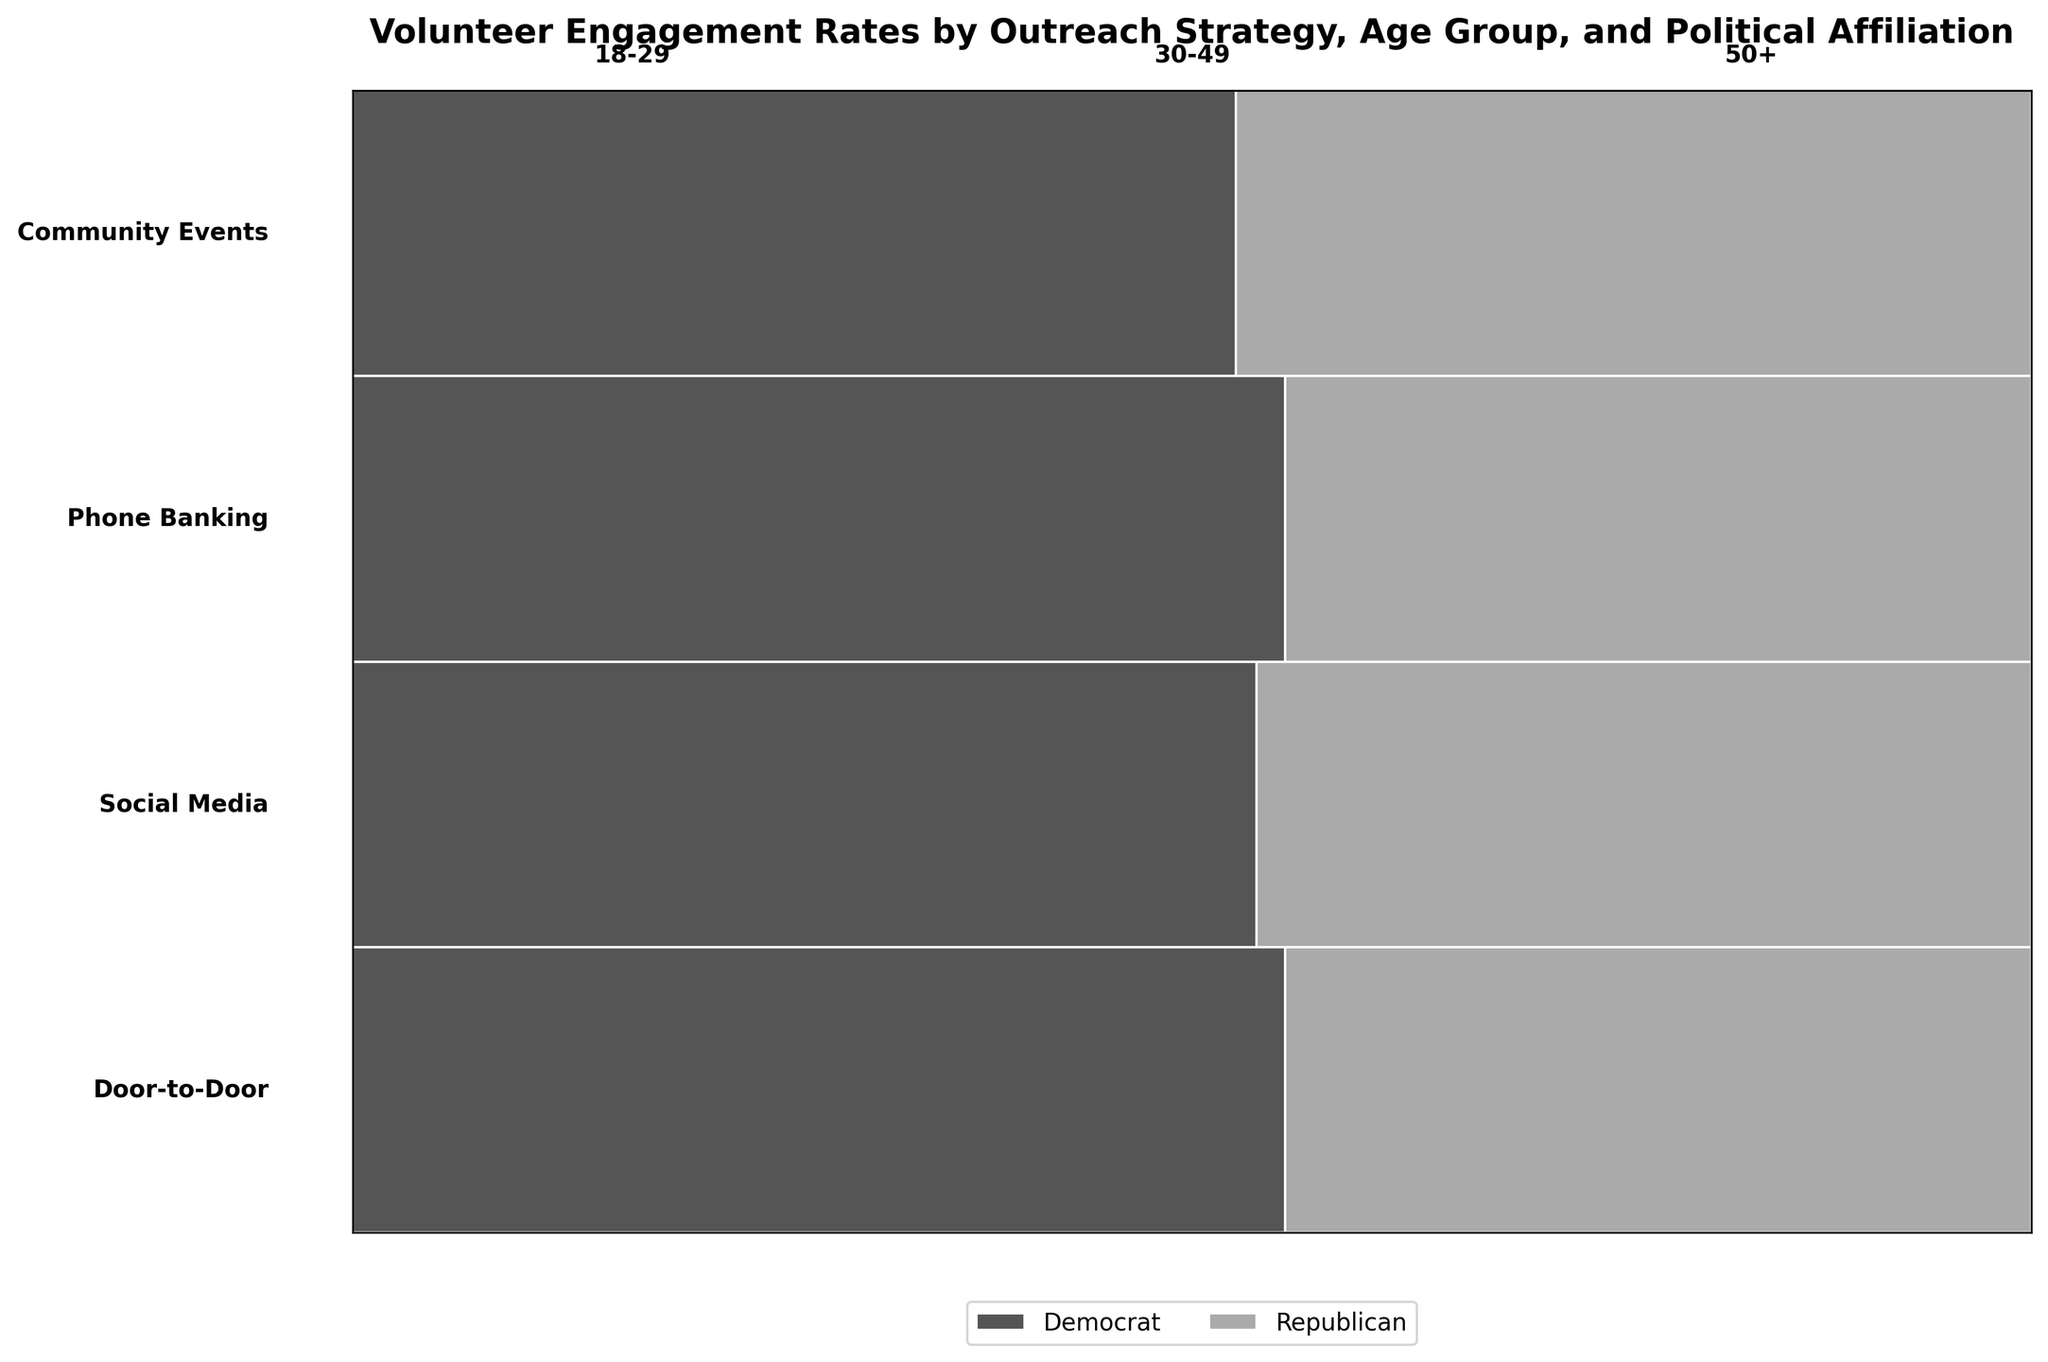Which outreach strategy has the highest engagement rate for the 18-29 age group? To find the highest engagement rate for the 18-29 age group, look at the respective sections for each outreach strategy for this age group and compare the engagement rates. The 'Social Media' strategy shows the highest engagement rate for the 18-29 age group.
Answer: Social Media Which age group shows the highest engagement rate in the 'Door-to-Door' strategy for Democrats? Examine the 'Door-to-Door' strategy and look at each age group's engagement rate for Democrats. The 50+ age group has the highest engagement rate among Democrats in the 'Door-to-Door' strategy.
Answer: 50+ What is the difference in engagement rates between Democrats and Republicans for the 'Social Media' strategy in the 30-49 age group? Locate the 'Social Media' strategy for the 30-49 age group and find the engagement rates for Democrats and Republicans. Subtract the Republican rate from the Democratic rate: 0.25 - 0.22 = 0.03.
Answer: 0.03 How do the engagement rates of 'Phone Banking' compare between Democrats and Republicans for the 50+ age group? Compare the engagement rates within the 'Phone Banking' for the 50+ age group. Democrats have a rate of 0.25, while Republicans have a rate of 0.22, making Democrats' engagement slightly higher.
Answer: Democrats have a higher rate Which outreach strategy has the lowest engagement rate for the 18-29 age group, irrespective of political affiliation? Identify the engagement rates for the 18-29 age group across all outreach strategies. The lowest rate is seen in the 'Phone Banking' strategy.
Answer: Phone Banking In which outreach strategy do Republicans in the 30-49 age group show higher engagement rates compared to Democrats in the same age group? Look for sections comparing engagement rates for Democrats and Republicans in the 30-49 age group across all strategies. None of the strategies show higher engagement rates for Republicans compared to Democrats in this age group.
Answer: None Which strategy has the most balanced engagement rates between Democrats and Republicans for the 50+ age group? Check the engagement rates for both Democrats and Republicans in the 50+ age group across all strategies and find the smallest difference. 'Door-to-Door' strategy is most balanced with similar rates (0.28 for Democrats and 0.25 for Republicans).
Answer: Door-to-Door Does the engagement rate trend for 'Community Events' increase or decrease with age for both political affiliations? Analyze the engagement rates for 'Community Events' across age groups for both Democrats and Republicans. Generally, there is an increasing trend with age for both affiliations.
Answer: Increase 